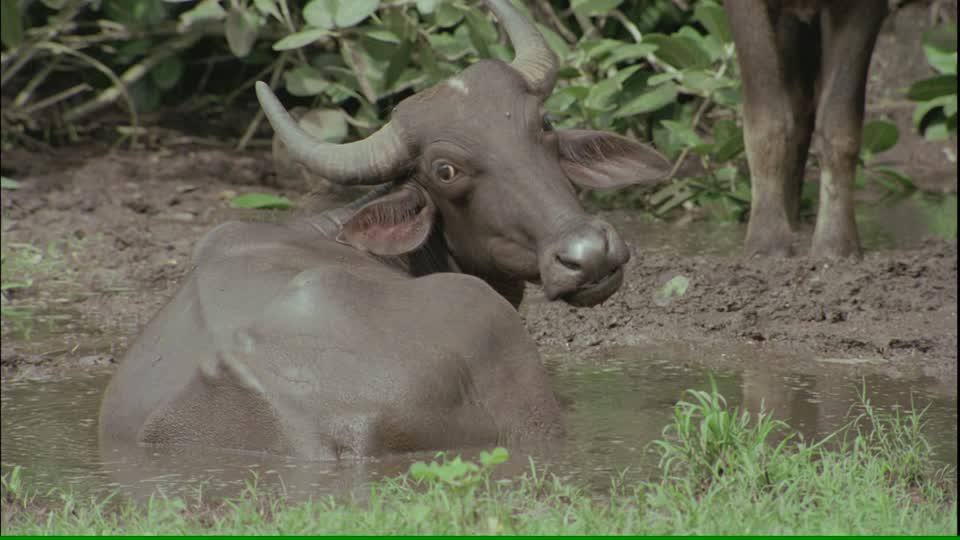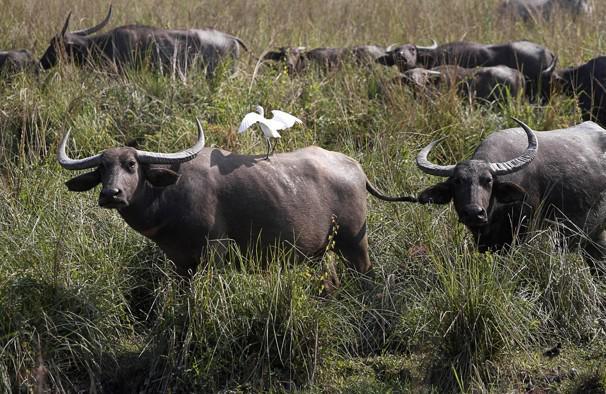The first image is the image on the left, the second image is the image on the right. Analyze the images presented: Is the assertion "A buffalo is completely covered in mud." valid? Answer yes or no. Yes. The first image is the image on the left, the second image is the image on the right. For the images displayed, is the sentence "IN at least one image there is a bull the is the same color as the dirt water it is in." factually correct? Answer yes or no. Yes. 